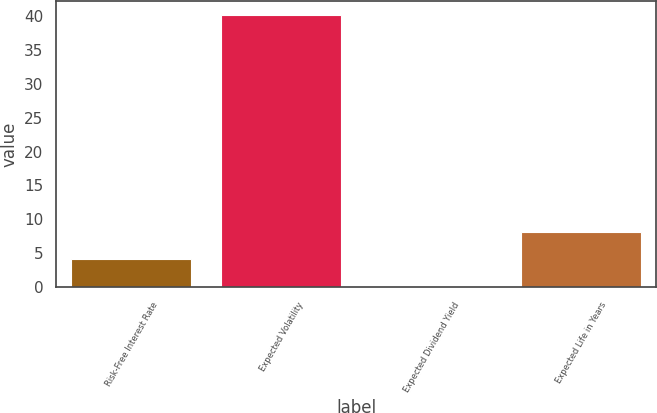Convert chart. <chart><loc_0><loc_0><loc_500><loc_500><bar_chart><fcel>Risk-Free Interest Rate<fcel>Expected Volatility<fcel>Expected Dividend Yield<fcel>Expected Life in Years<nl><fcel>4.11<fcel>40.2<fcel>0.1<fcel>8.12<nl></chart> 